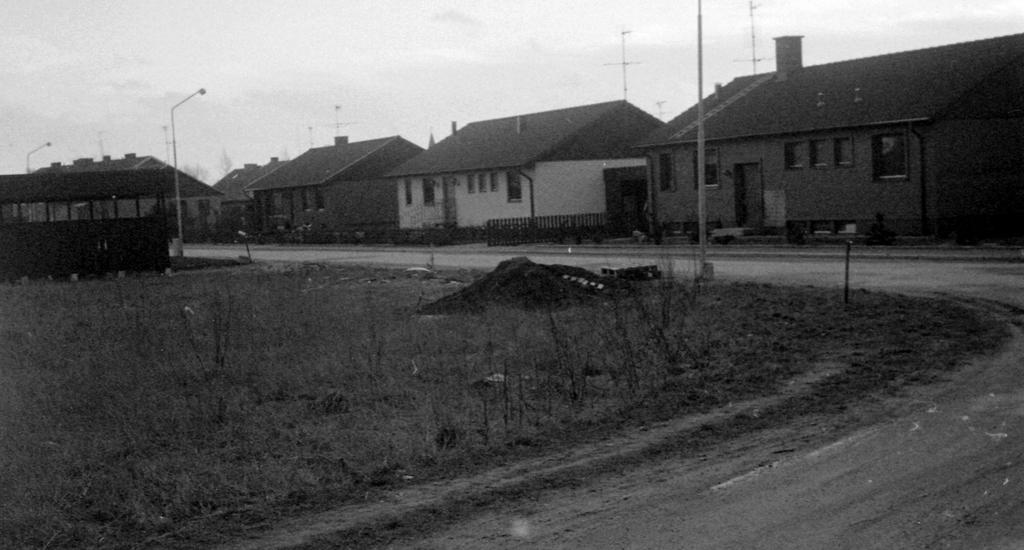What type of terrain is visible in the image? There is grass and sand visible in the image. What structures can be seen in the image? There are poles in the image. What can be seen in the background of the image? There are houses, a railing, and the sky visible in the background of the image. What is the color scheme of the image? The image is black and white. How many legs are visible in the image? There are no legs visible in the image. What type of eggs can be seen in the image? There are no eggs present in the image. 